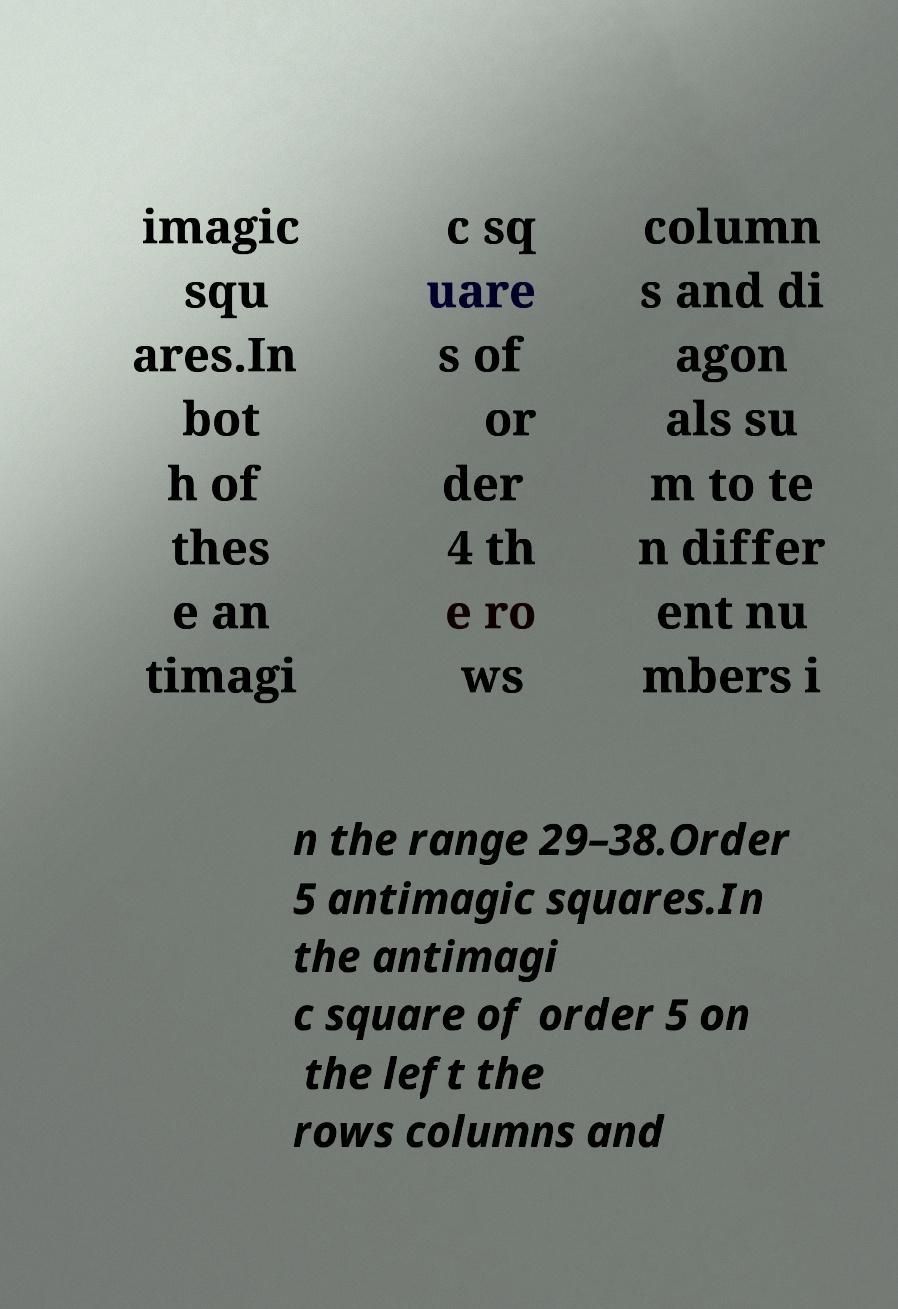Can you read and provide the text displayed in the image?This photo seems to have some interesting text. Can you extract and type it out for me? imagic squ ares.In bot h of thes e an timagi c sq uare s of or der 4 th e ro ws column s and di agon als su m to te n differ ent nu mbers i n the range 29–38.Order 5 antimagic squares.In the antimagi c square of order 5 on the left the rows columns and 